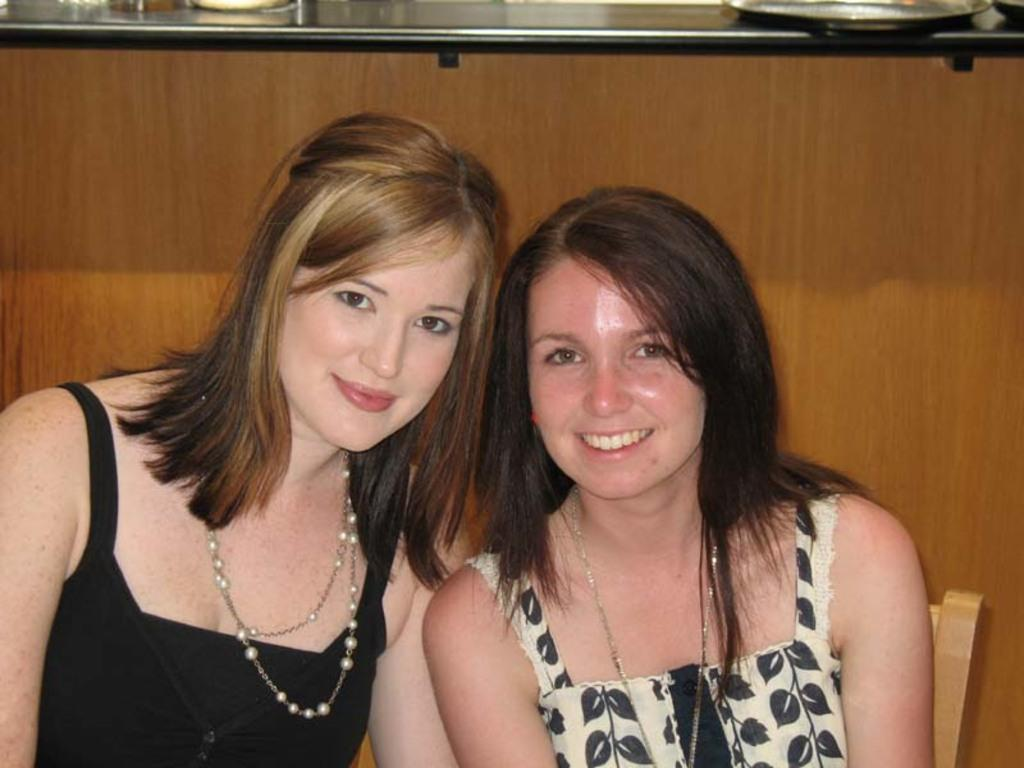How many people are in the image? There are two ladies in the image. What are the ladies wearing? Both ladies are wearing chains. What expression do the ladies have? Both ladies are smiling. What can be seen in the background of the image? There is a wooden wall in the background. Is there any architectural feature associated with the wooden wall? Yes, there is a platform associated with the wooden wall. What type of attraction can be seen in the mouth of one of the ladies in the image? There is no attraction visible in the mouth of either lady in the image. 